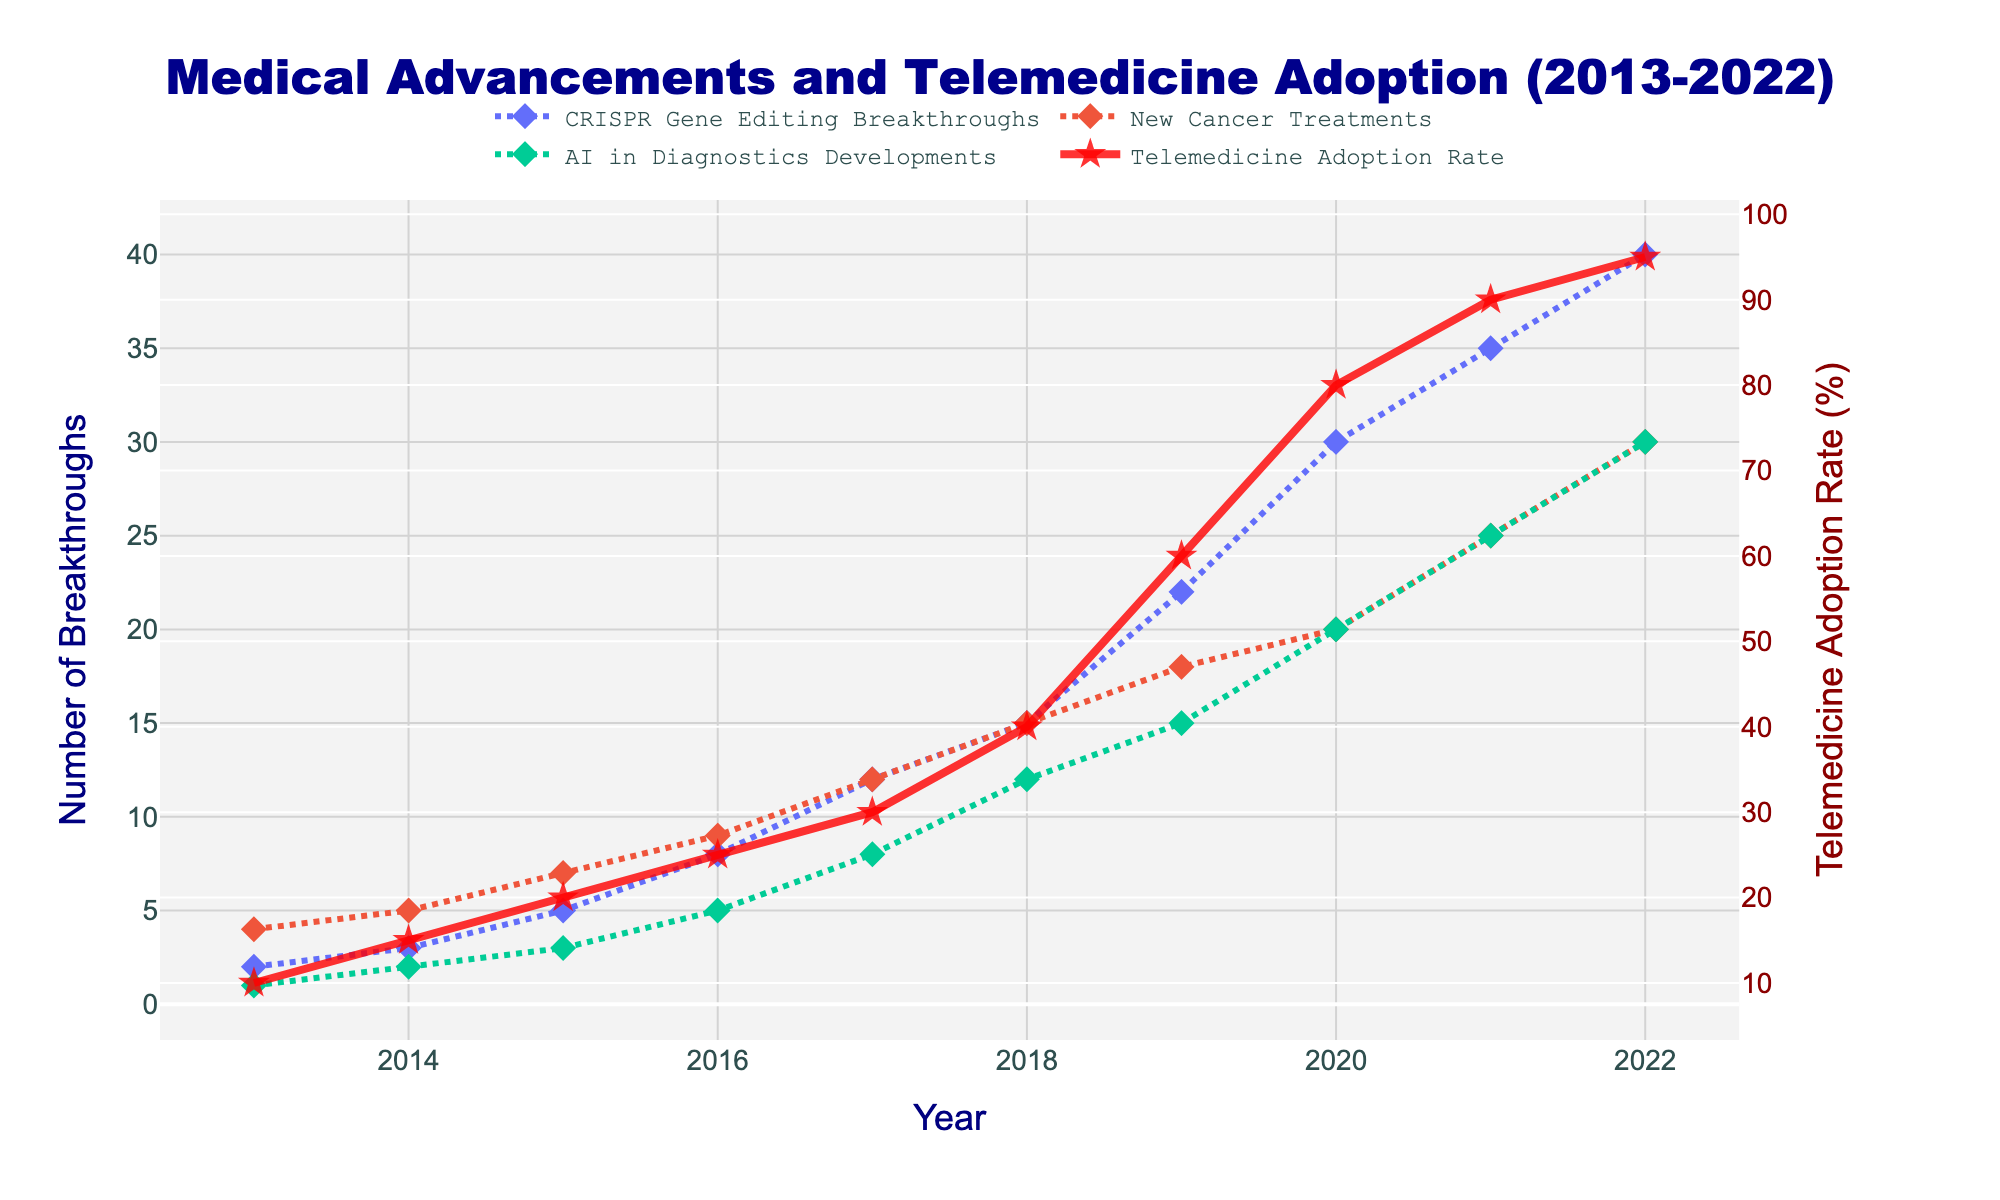What is the title of the figure? The title can be found at the top of the figure.
Answer: Medical Advancements and Telemedicine Adoption (2013-2022) What are the four main advancements/trends tracked in the plot? The plot shows four lines, each representing a different advancement or trend, which are listed in the legend.
Answer: CRISPR Gene Editing Breakthroughs, New Cancer Treatments, AI in Diagnostics Developments, Telemedicine Adoption Rate Which medical advancement saw the highest number of breakthroughs in 2022? To find this, look at the highest value for each advancement line in 2022.
Answer: CRISPR Gene Editing Breakthroughs What is the difference in Telemedicine Adoption Rate between 2013 and 2022? Find the Telemedicine Adoption Rate in 2013 and 2022, then subtract the former from the latter.
Answer: 85% Which year saw the highest increase in new cancer treatments? Evaluate the increase in the number of new cancer treatments each year and identify the year with the largest increase.
Answer: 2019 How did the trends for AI in Diagnostics Developments and Telemedicine Adoption Rate differ from 2013 to 2022? Compare the lines for AI in Diagnostics Developments and Telemedicine Adoption Rate over the years to see differences in their trends. AI developments show a steady increase, while telemedicine adoption shows a sharper rise.
Answer: AI increased steadily, Telemedicine adoption had a sharper rise, especially after 2018 Which year had the equal number of breakthroughs in CRISPR Gene Editing and AI in Diagnostics? Look at the values for both CRISPR Gene Editing and AI in Diagnostics by year and identify the year where their values are equal.
Answer: 2018 What is the average number of CRISPR Gene Editing Breakthroughs from 2013 to 2022? Sum the number of breakthroughs for all years and then divide by the number of years.
Answer: 17.2 How many times did the New Cancer Treatments breakthroughs exceed 15 within the decade? Count the number of years where the New Cancer Treatments breakthroughs were greater than 15.
Answer: 4 times By how much did the AI in Diagnostics Developments increase from 2013 to 2020? Subtract the number of developments in 2013 from the number of developments in 2020.
Answer: 19 